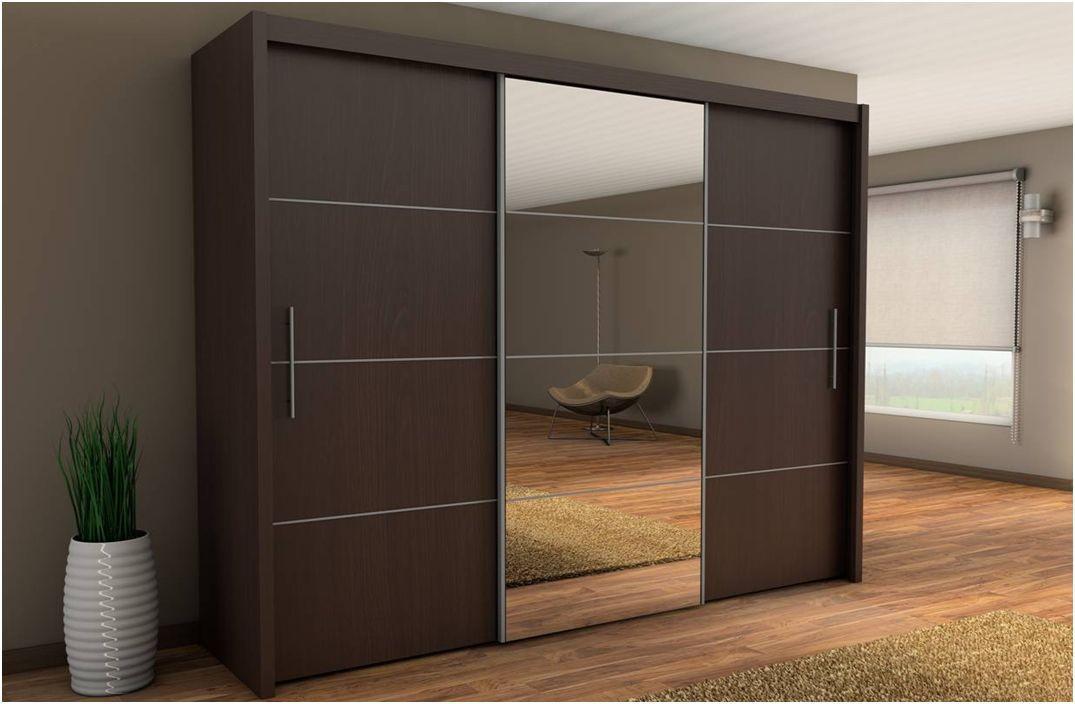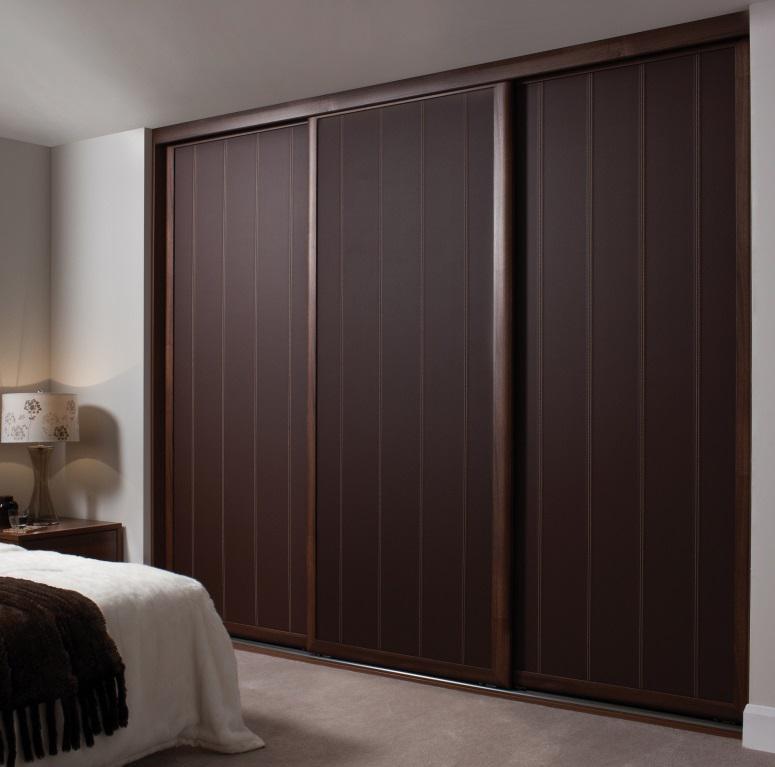The first image is the image on the left, the second image is the image on the right. Given the left and right images, does the statement "One image shows a sliding door wardrobe that sits against a wall and has two dark wood sections and one section that is not dark." hold true? Answer yes or no. Yes. The first image is the image on the left, the second image is the image on the right. Evaluate the accuracy of this statement regarding the images: "In at least one image there is a single hanging wooden door.". Is it true? Answer yes or no. No. 